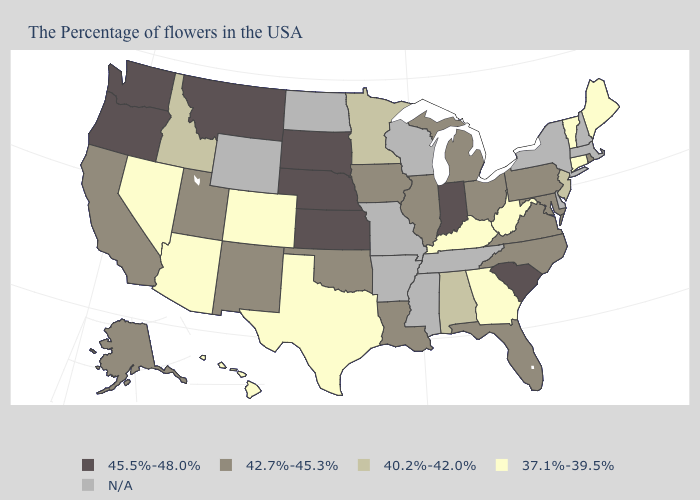What is the highest value in the West ?
Write a very short answer. 45.5%-48.0%. Name the states that have a value in the range N/A?
Quick response, please. Massachusetts, New Hampshire, New York, Delaware, Tennessee, Wisconsin, Mississippi, Missouri, Arkansas, North Dakota, Wyoming. What is the value of Utah?
Be succinct. 42.7%-45.3%. Which states have the highest value in the USA?
Give a very brief answer. South Carolina, Indiana, Kansas, Nebraska, South Dakota, Montana, Washington, Oregon. Among the states that border Minnesota , does South Dakota have the highest value?
Be succinct. Yes. Does Minnesota have the highest value in the MidWest?
Write a very short answer. No. Does Hawaii have the lowest value in the West?
Write a very short answer. Yes. What is the value of Nebraska?
Keep it brief. 45.5%-48.0%. Among the states that border New York , does Vermont have the highest value?
Keep it brief. No. What is the highest value in states that border Pennsylvania?
Be succinct. 42.7%-45.3%. What is the value of Colorado?
Concise answer only. 37.1%-39.5%. Name the states that have a value in the range N/A?
Concise answer only. Massachusetts, New Hampshire, New York, Delaware, Tennessee, Wisconsin, Mississippi, Missouri, Arkansas, North Dakota, Wyoming. 